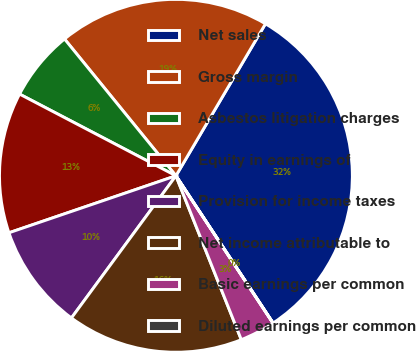Convert chart. <chart><loc_0><loc_0><loc_500><loc_500><pie_chart><fcel>Net sales<fcel>Gross margin<fcel>Asbestos litigation charges<fcel>Equity in earnings of<fcel>Provision for income taxes<fcel>Net income attributable to<fcel>Basic earnings per common<fcel>Diluted earnings per common<nl><fcel>32.25%<fcel>19.35%<fcel>6.46%<fcel>12.9%<fcel>9.68%<fcel>16.13%<fcel>3.23%<fcel>0.01%<nl></chart> 